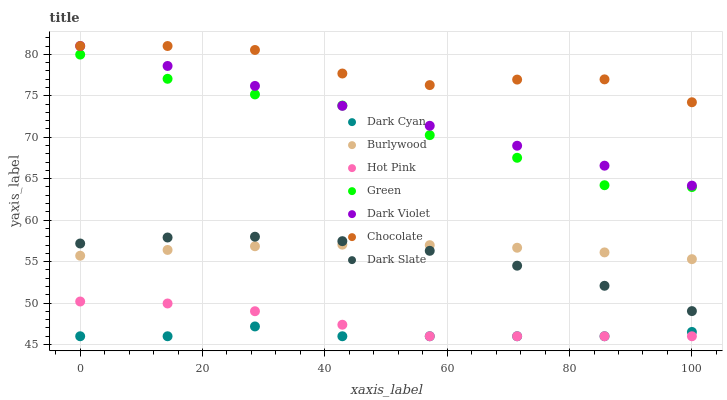Does Dark Cyan have the minimum area under the curve?
Answer yes or no. Yes. Does Chocolate have the maximum area under the curve?
Answer yes or no. Yes. Does Hot Pink have the minimum area under the curve?
Answer yes or no. No. Does Hot Pink have the maximum area under the curve?
Answer yes or no. No. Is Dark Violet the smoothest?
Answer yes or no. Yes. Is Chocolate the roughest?
Answer yes or no. Yes. Is Hot Pink the smoothest?
Answer yes or no. No. Is Hot Pink the roughest?
Answer yes or no. No. Does Hot Pink have the lowest value?
Answer yes or no. Yes. Does Dark Violet have the lowest value?
Answer yes or no. No. Does Chocolate have the highest value?
Answer yes or no. Yes. Does Hot Pink have the highest value?
Answer yes or no. No. Is Dark Slate less than Dark Violet?
Answer yes or no. Yes. Is Burlywood greater than Dark Cyan?
Answer yes or no. Yes. Does Dark Violet intersect Chocolate?
Answer yes or no. Yes. Is Dark Violet less than Chocolate?
Answer yes or no. No. Is Dark Violet greater than Chocolate?
Answer yes or no. No. Does Dark Slate intersect Dark Violet?
Answer yes or no. No. 